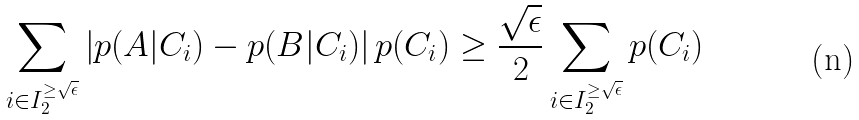Convert formula to latex. <formula><loc_0><loc_0><loc_500><loc_500>\sum _ { i \in I _ { 2 } ^ { \geq \sqrt { \epsilon } } } \left | p ( A | C _ { i } ) - p ( B | C _ { i } ) \right | p ( C _ { i } ) \geq \frac { \sqrt { \epsilon } } { 2 } \sum _ { i \in I _ { 2 } ^ { \geq \sqrt { \epsilon } } } p ( C _ { i } )</formula> 